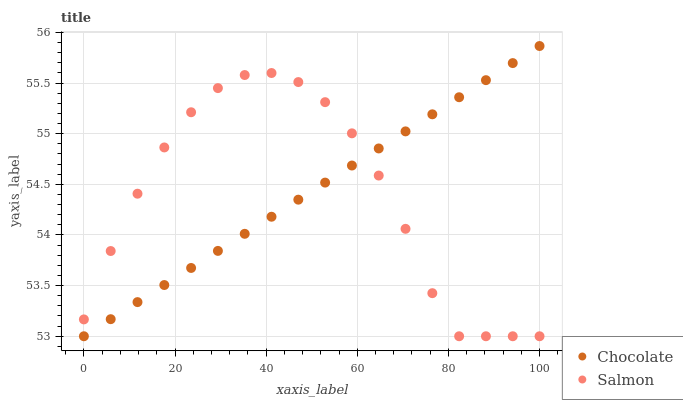Does Salmon have the minimum area under the curve?
Answer yes or no. Yes. Does Chocolate have the maximum area under the curve?
Answer yes or no. Yes. Does Chocolate have the minimum area under the curve?
Answer yes or no. No. Is Chocolate the smoothest?
Answer yes or no. Yes. Is Salmon the roughest?
Answer yes or no. Yes. Is Chocolate the roughest?
Answer yes or no. No. Does Salmon have the lowest value?
Answer yes or no. Yes. Does Chocolate have the highest value?
Answer yes or no. Yes. Does Salmon intersect Chocolate?
Answer yes or no. Yes. Is Salmon less than Chocolate?
Answer yes or no. No. Is Salmon greater than Chocolate?
Answer yes or no. No. 